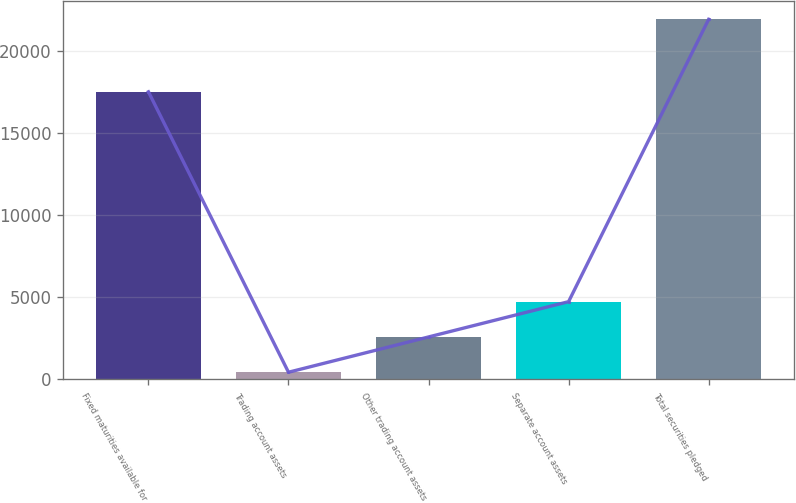Convert chart. <chart><loc_0><loc_0><loc_500><loc_500><bar_chart><fcel>Fixed maturities available for<fcel>Trading account assets<fcel>Other trading account assets<fcel>Separate account assets<fcel>Total securities pledged<nl><fcel>17509<fcel>439<fcel>2586.8<fcel>4734.6<fcel>21917<nl></chart> 